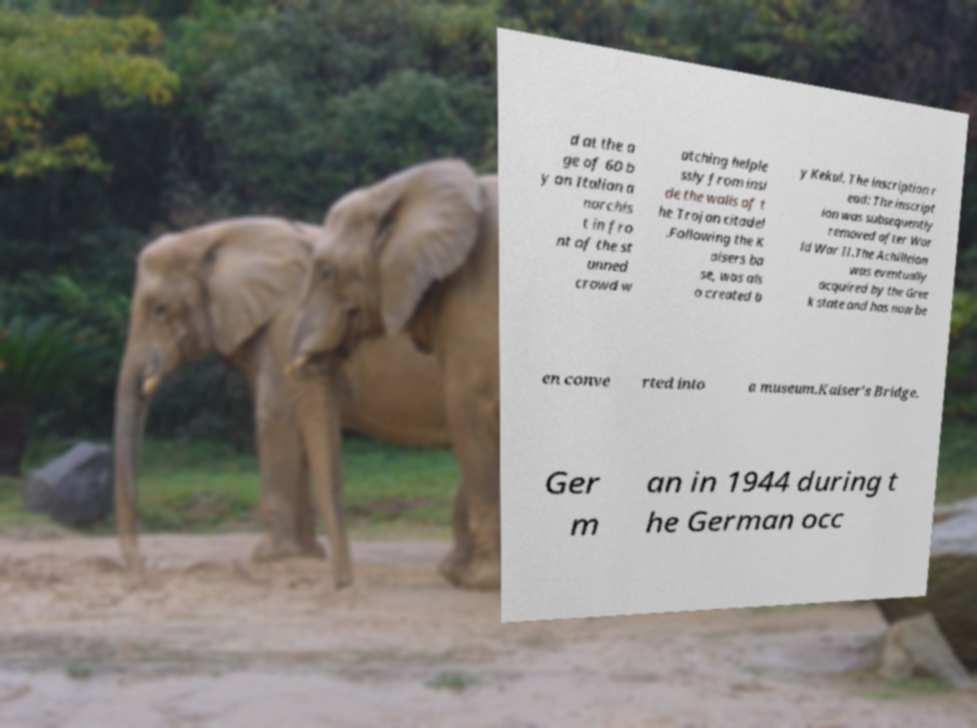Could you extract and type out the text from this image? d at the a ge of 60 b y an Italian a narchis t in fro nt of the st unned crowd w atching helple ssly from insi de the walls of t he Trojan citadel .Following the K aisers ba se, was als o created b y Kekul. The inscription r ead: The inscript ion was subsequently removed after Wor ld War II.The Achilleion was eventually acquired by the Gree k state and has now be en conve rted into a museum.Kaiser's Bridge. Ger m an in 1944 during t he German occ 